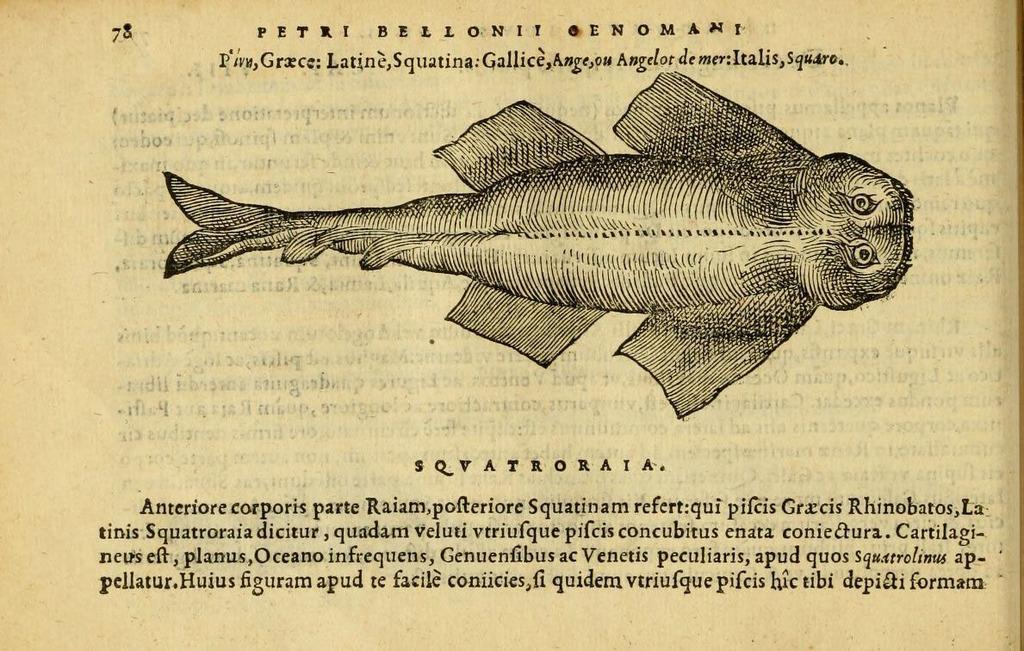How would you summarize this image in a sentence or two? In this image, we can see a photo, in that photo, we can see a fish and we can see some text. 